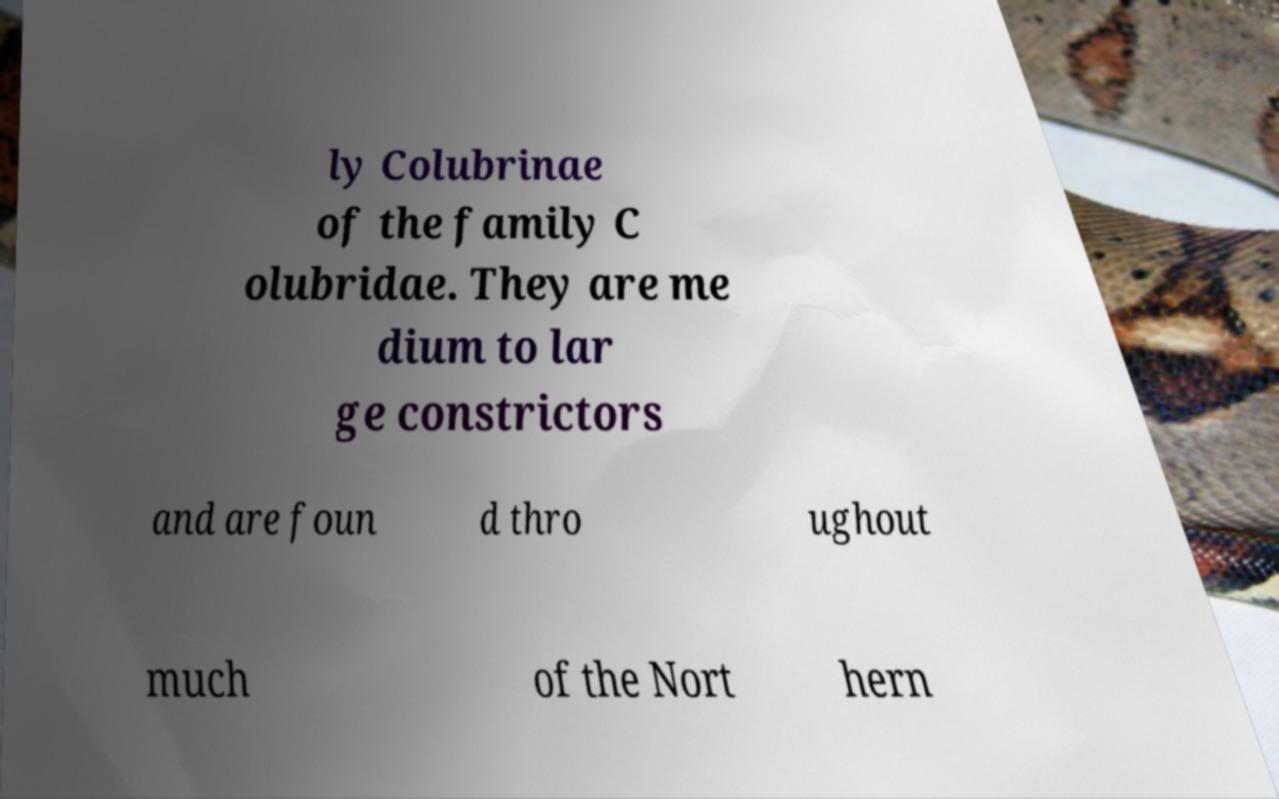I need the written content from this picture converted into text. Can you do that? ly Colubrinae of the family C olubridae. They are me dium to lar ge constrictors and are foun d thro ughout much of the Nort hern 